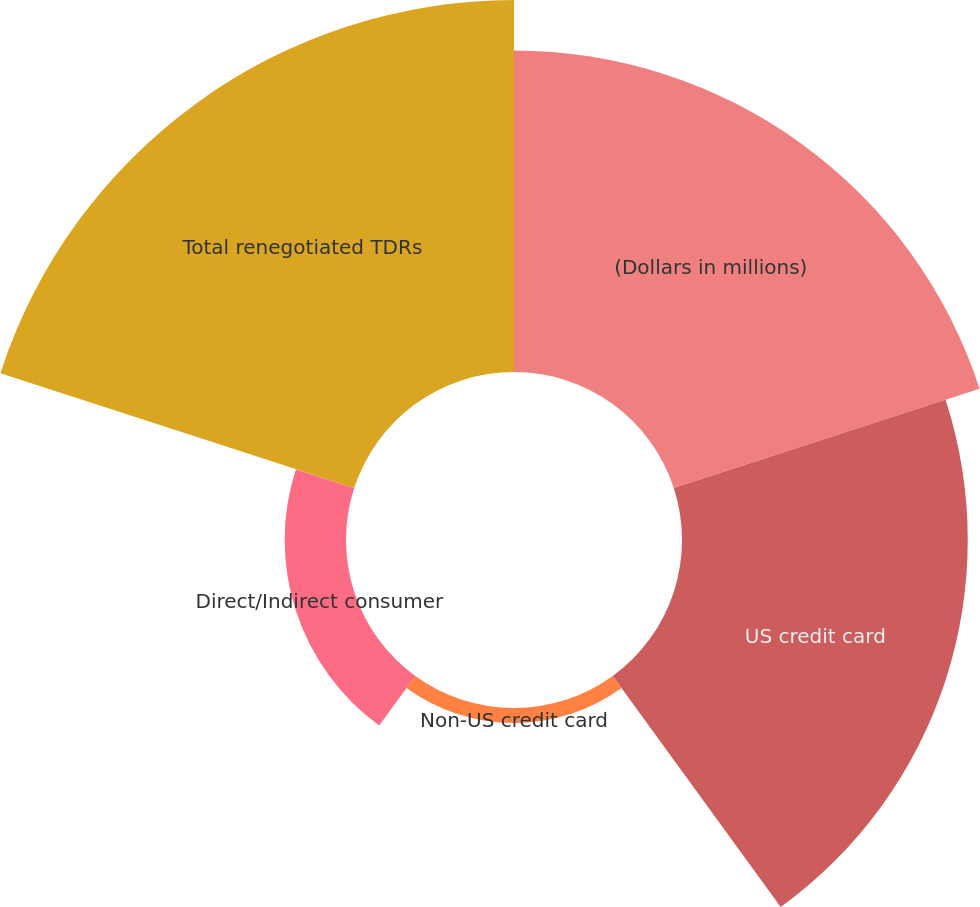Convert chart. <chart><loc_0><loc_0><loc_500><loc_500><pie_chart><fcel>(Dollars in millions)<fcel>US credit card<fcel>Non-US credit card<fcel>Direct/Indirect consumer<fcel>Total renegotiated TDRs<nl><fcel>30.46%<fcel>27.07%<fcel>1.42%<fcel>5.81%<fcel>35.24%<nl></chart> 